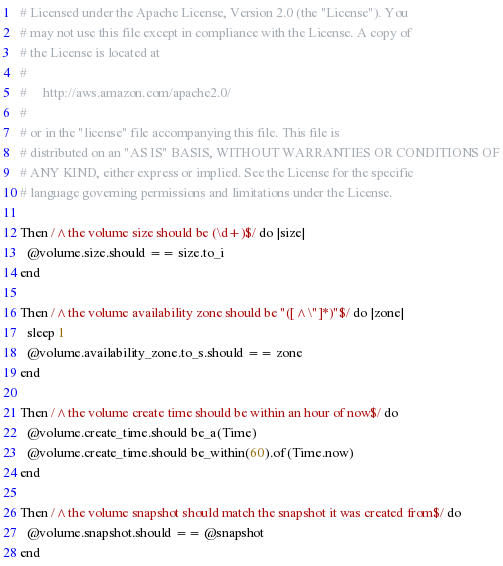Convert code to text. <code><loc_0><loc_0><loc_500><loc_500><_Ruby_># Licensed under the Apache License, Version 2.0 (the "License"). You
# may not use this file except in compliance with the License. A copy of
# the License is located at
#
#     http://aws.amazon.com/apache2.0/
#
# or in the "license" file accompanying this file. This file is
# distributed on an "AS IS" BASIS, WITHOUT WARRANTIES OR CONDITIONS OF
# ANY KIND, either express or implied. See the License for the specific
# language governing permissions and limitations under the License.

Then /^the volume size should be (\d+)$/ do |size|
  @volume.size.should == size.to_i
end

Then /^the volume availability zone should be "([^\"]*)"$/ do |zone|
  sleep 1
  @volume.availability_zone.to_s.should == zone
end

Then /^the volume create time should be within an hour of now$/ do
  @volume.create_time.should be_a(Time)
  @volume.create_time.should be_within(60).of(Time.now)
end

Then /^the volume snapshot should match the snapshot it was created from$/ do
  @volume.snapshot.should == @snapshot
end
</code> 